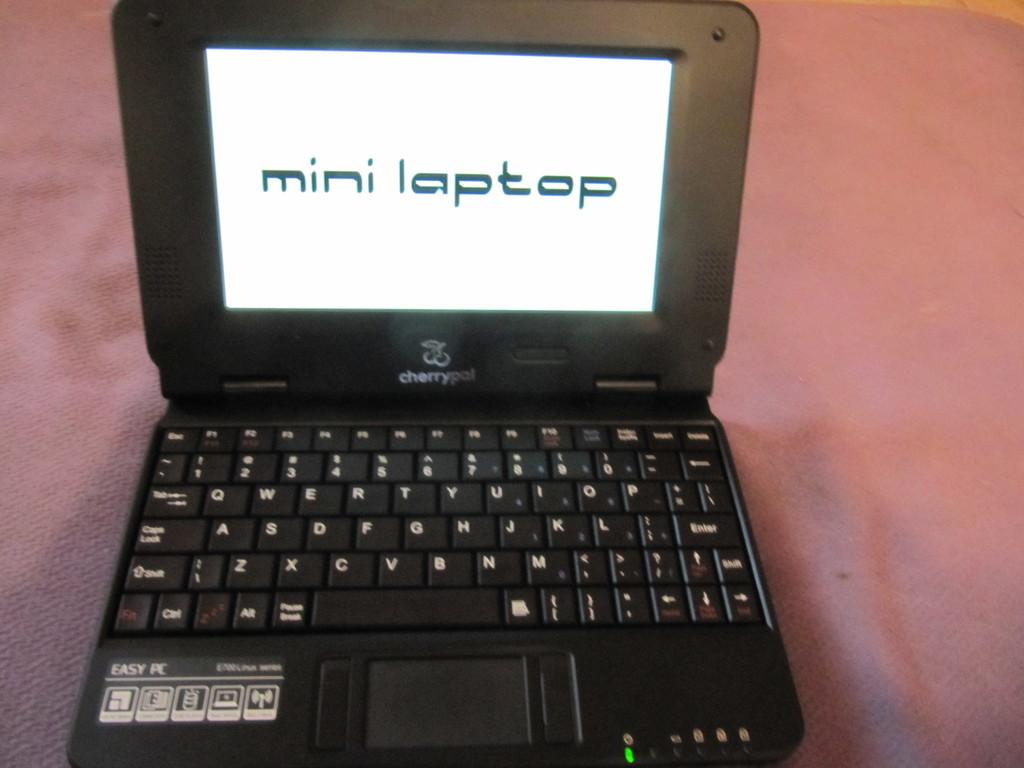What type of laptop is this?
Your answer should be compact. Mini laptop. What kind of "pc" shows on laptop?
Your answer should be compact. Mini laptop. 